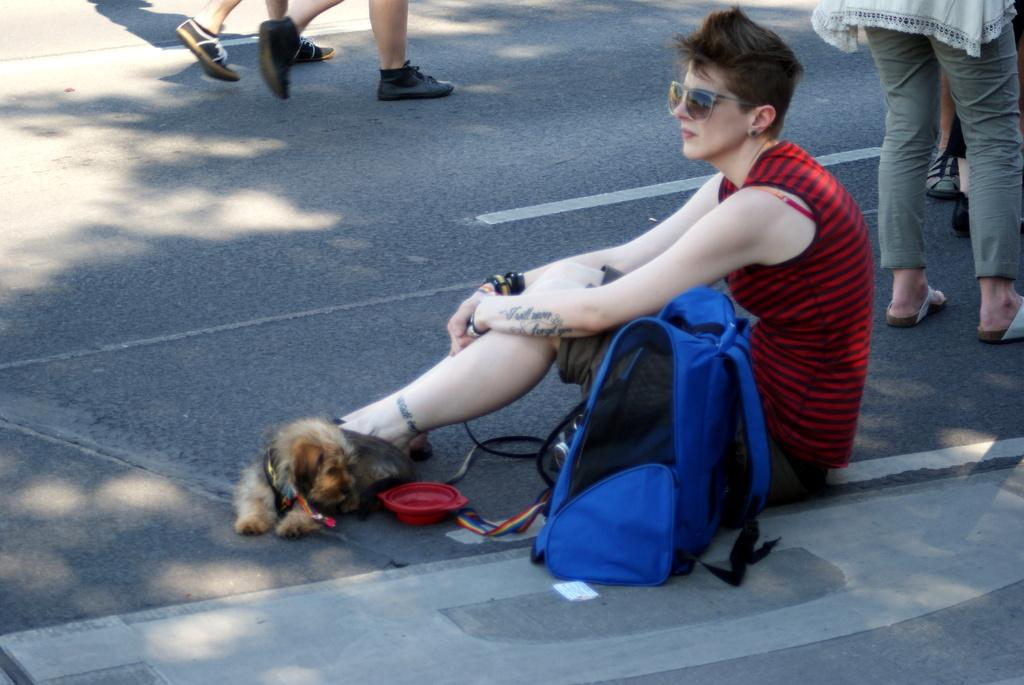What is the woman doing in the image? The woman is sitting on the road in the image. Is there any animal with the woman? Yes, there is a dog beside the woman. What is the woman holding or carrying? The woman has a bag. What can be seen in the background of the image? In the background of the image, there are people walking and people standing. What type of system is the woman using to move around in the image? The woman is sitting on the road, so there is no system for her to move around in the image. 